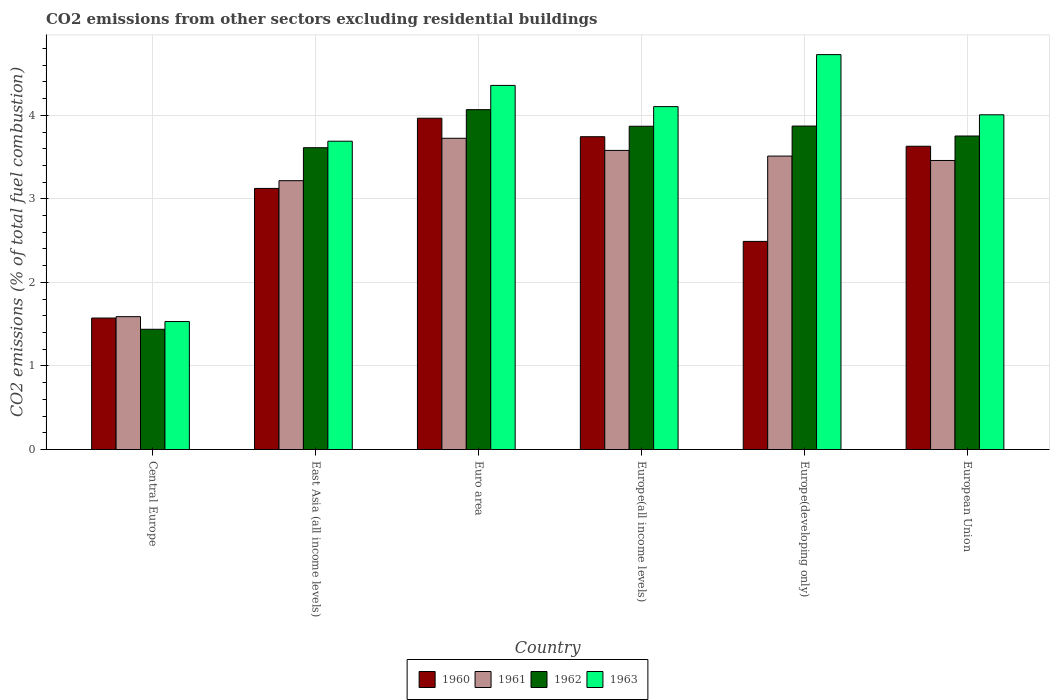Are the number of bars on each tick of the X-axis equal?
Keep it short and to the point. Yes. How many bars are there on the 5th tick from the left?
Offer a terse response. 4. How many bars are there on the 1st tick from the right?
Offer a very short reply. 4. What is the total CO2 emitted in 1961 in European Union?
Offer a terse response. 3.46. Across all countries, what is the maximum total CO2 emitted in 1960?
Ensure brevity in your answer.  3.97. Across all countries, what is the minimum total CO2 emitted in 1961?
Make the answer very short. 1.59. In which country was the total CO2 emitted in 1963 maximum?
Make the answer very short. Europe(developing only). In which country was the total CO2 emitted in 1961 minimum?
Your response must be concise. Central Europe. What is the total total CO2 emitted in 1960 in the graph?
Your response must be concise. 18.53. What is the difference between the total CO2 emitted in 1962 in East Asia (all income levels) and that in Europe(developing only)?
Provide a succinct answer. -0.26. What is the difference between the total CO2 emitted in 1962 in Europe(developing only) and the total CO2 emitted in 1960 in Euro area?
Your response must be concise. -0.09. What is the average total CO2 emitted in 1962 per country?
Offer a very short reply. 3.44. What is the difference between the total CO2 emitted of/in 1962 and total CO2 emitted of/in 1961 in Europe(developing only)?
Keep it short and to the point. 0.36. In how many countries, is the total CO2 emitted in 1960 greater than 1.6?
Provide a short and direct response. 5. What is the ratio of the total CO2 emitted in 1962 in Europe(all income levels) to that in European Union?
Offer a very short reply. 1.03. What is the difference between the highest and the second highest total CO2 emitted in 1960?
Provide a succinct answer. -0.22. What is the difference between the highest and the lowest total CO2 emitted in 1963?
Give a very brief answer. 3.19. In how many countries, is the total CO2 emitted in 1962 greater than the average total CO2 emitted in 1962 taken over all countries?
Make the answer very short. 5. Is the sum of the total CO2 emitted in 1960 in East Asia (all income levels) and Euro area greater than the maximum total CO2 emitted in 1963 across all countries?
Provide a short and direct response. Yes. Is it the case that in every country, the sum of the total CO2 emitted in 1960 and total CO2 emitted in 1963 is greater than the sum of total CO2 emitted in 1962 and total CO2 emitted in 1961?
Keep it short and to the point. No. What does the 4th bar from the right in Euro area represents?
Offer a terse response. 1960. Is it the case that in every country, the sum of the total CO2 emitted in 1962 and total CO2 emitted in 1960 is greater than the total CO2 emitted in 1961?
Offer a very short reply. Yes. How many bars are there?
Your response must be concise. 24. Are all the bars in the graph horizontal?
Offer a very short reply. No. How many countries are there in the graph?
Offer a terse response. 6. Does the graph contain grids?
Keep it short and to the point. Yes. What is the title of the graph?
Keep it short and to the point. CO2 emissions from other sectors excluding residential buildings. Does "1980" appear as one of the legend labels in the graph?
Your answer should be compact. No. What is the label or title of the Y-axis?
Your answer should be compact. CO2 emissions (% of total fuel combustion). What is the CO2 emissions (% of total fuel combustion) of 1960 in Central Europe?
Provide a short and direct response. 1.57. What is the CO2 emissions (% of total fuel combustion) of 1961 in Central Europe?
Keep it short and to the point. 1.59. What is the CO2 emissions (% of total fuel combustion) in 1962 in Central Europe?
Provide a short and direct response. 1.44. What is the CO2 emissions (% of total fuel combustion) of 1963 in Central Europe?
Provide a short and direct response. 1.53. What is the CO2 emissions (% of total fuel combustion) in 1960 in East Asia (all income levels)?
Keep it short and to the point. 3.13. What is the CO2 emissions (% of total fuel combustion) in 1961 in East Asia (all income levels)?
Provide a succinct answer. 3.22. What is the CO2 emissions (% of total fuel combustion) in 1962 in East Asia (all income levels)?
Provide a succinct answer. 3.61. What is the CO2 emissions (% of total fuel combustion) of 1963 in East Asia (all income levels)?
Keep it short and to the point. 3.69. What is the CO2 emissions (% of total fuel combustion) in 1960 in Euro area?
Offer a very short reply. 3.97. What is the CO2 emissions (% of total fuel combustion) of 1961 in Euro area?
Keep it short and to the point. 3.73. What is the CO2 emissions (% of total fuel combustion) of 1962 in Euro area?
Ensure brevity in your answer.  4.07. What is the CO2 emissions (% of total fuel combustion) in 1963 in Euro area?
Your answer should be very brief. 4.36. What is the CO2 emissions (% of total fuel combustion) in 1960 in Europe(all income levels)?
Keep it short and to the point. 3.74. What is the CO2 emissions (% of total fuel combustion) in 1961 in Europe(all income levels)?
Your answer should be compact. 3.58. What is the CO2 emissions (% of total fuel combustion) in 1962 in Europe(all income levels)?
Keep it short and to the point. 3.87. What is the CO2 emissions (% of total fuel combustion) in 1963 in Europe(all income levels)?
Provide a short and direct response. 4.1. What is the CO2 emissions (% of total fuel combustion) of 1960 in Europe(developing only)?
Your response must be concise. 2.49. What is the CO2 emissions (% of total fuel combustion) in 1961 in Europe(developing only)?
Your answer should be compact. 3.51. What is the CO2 emissions (% of total fuel combustion) of 1962 in Europe(developing only)?
Ensure brevity in your answer.  3.87. What is the CO2 emissions (% of total fuel combustion) in 1963 in Europe(developing only)?
Your response must be concise. 4.73. What is the CO2 emissions (% of total fuel combustion) of 1960 in European Union?
Give a very brief answer. 3.63. What is the CO2 emissions (% of total fuel combustion) in 1961 in European Union?
Keep it short and to the point. 3.46. What is the CO2 emissions (% of total fuel combustion) of 1962 in European Union?
Give a very brief answer. 3.75. What is the CO2 emissions (% of total fuel combustion) of 1963 in European Union?
Your response must be concise. 4.01. Across all countries, what is the maximum CO2 emissions (% of total fuel combustion) of 1960?
Keep it short and to the point. 3.97. Across all countries, what is the maximum CO2 emissions (% of total fuel combustion) of 1961?
Your answer should be very brief. 3.73. Across all countries, what is the maximum CO2 emissions (% of total fuel combustion) in 1962?
Offer a terse response. 4.07. Across all countries, what is the maximum CO2 emissions (% of total fuel combustion) of 1963?
Offer a very short reply. 4.73. Across all countries, what is the minimum CO2 emissions (% of total fuel combustion) in 1960?
Ensure brevity in your answer.  1.57. Across all countries, what is the minimum CO2 emissions (% of total fuel combustion) of 1961?
Ensure brevity in your answer.  1.59. Across all countries, what is the minimum CO2 emissions (% of total fuel combustion) in 1962?
Provide a succinct answer. 1.44. Across all countries, what is the minimum CO2 emissions (% of total fuel combustion) of 1963?
Give a very brief answer. 1.53. What is the total CO2 emissions (% of total fuel combustion) of 1960 in the graph?
Give a very brief answer. 18.53. What is the total CO2 emissions (% of total fuel combustion) in 1961 in the graph?
Make the answer very short. 19.08. What is the total CO2 emissions (% of total fuel combustion) in 1962 in the graph?
Provide a short and direct response. 20.61. What is the total CO2 emissions (% of total fuel combustion) in 1963 in the graph?
Offer a terse response. 22.42. What is the difference between the CO2 emissions (% of total fuel combustion) in 1960 in Central Europe and that in East Asia (all income levels)?
Keep it short and to the point. -1.55. What is the difference between the CO2 emissions (% of total fuel combustion) of 1961 in Central Europe and that in East Asia (all income levels)?
Keep it short and to the point. -1.63. What is the difference between the CO2 emissions (% of total fuel combustion) in 1962 in Central Europe and that in East Asia (all income levels)?
Offer a terse response. -2.17. What is the difference between the CO2 emissions (% of total fuel combustion) of 1963 in Central Europe and that in East Asia (all income levels)?
Offer a terse response. -2.16. What is the difference between the CO2 emissions (% of total fuel combustion) of 1960 in Central Europe and that in Euro area?
Your answer should be very brief. -2.39. What is the difference between the CO2 emissions (% of total fuel combustion) in 1961 in Central Europe and that in Euro area?
Provide a short and direct response. -2.14. What is the difference between the CO2 emissions (% of total fuel combustion) in 1962 in Central Europe and that in Euro area?
Make the answer very short. -2.63. What is the difference between the CO2 emissions (% of total fuel combustion) in 1963 in Central Europe and that in Euro area?
Ensure brevity in your answer.  -2.83. What is the difference between the CO2 emissions (% of total fuel combustion) of 1960 in Central Europe and that in Europe(all income levels)?
Offer a terse response. -2.17. What is the difference between the CO2 emissions (% of total fuel combustion) of 1961 in Central Europe and that in Europe(all income levels)?
Make the answer very short. -1.99. What is the difference between the CO2 emissions (% of total fuel combustion) in 1962 in Central Europe and that in Europe(all income levels)?
Your answer should be very brief. -2.43. What is the difference between the CO2 emissions (% of total fuel combustion) in 1963 in Central Europe and that in Europe(all income levels)?
Your answer should be very brief. -2.57. What is the difference between the CO2 emissions (% of total fuel combustion) of 1960 in Central Europe and that in Europe(developing only)?
Offer a very short reply. -0.92. What is the difference between the CO2 emissions (% of total fuel combustion) in 1961 in Central Europe and that in Europe(developing only)?
Give a very brief answer. -1.92. What is the difference between the CO2 emissions (% of total fuel combustion) of 1962 in Central Europe and that in Europe(developing only)?
Make the answer very short. -2.43. What is the difference between the CO2 emissions (% of total fuel combustion) in 1963 in Central Europe and that in Europe(developing only)?
Ensure brevity in your answer.  -3.19. What is the difference between the CO2 emissions (% of total fuel combustion) of 1960 in Central Europe and that in European Union?
Your answer should be compact. -2.06. What is the difference between the CO2 emissions (% of total fuel combustion) in 1961 in Central Europe and that in European Union?
Offer a terse response. -1.87. What is the difference between the CO2 emissions (% of total fuel combustion) in 1962 in Central Europe and that in European Union?
Your answer should be compact. -2.31. What is the difference between the CO2 emissions (% of total fuel combustion) of 1963 in Central Europe and that in European Union?
Your answer should be very brief. -2.47. What is the difference between the CO2 emissions (% of total fuel combustion) in 1960 in East Asia (all income levels) and that in Euro area?
Your answer should be very brief. -0.84. What is the difference between the CO2 emissions (% of total fuel combustion) of 1961 in East Asia (all income levels) and that in Euro area?
Your answer should be compact. -0.51. What is the difference between the CO2 emissions (% of total fuel combustion) of 1962 in East Asia (all income levels) and that in Euro area?
Keep it short and to the point. -0.46. What is the difference between the CO2 emissions (% of total fuel combustion) in 1963 in East Asia (all income levels) and that in Euro area?
Provide a short and direct response. -0.67. What is the difference between the CO2 emissions (% of total fuel combustion) in 1960 in East Asia (all income levels) and that in Europe(all income levels)?
Your answer should be very brief. -0.62. What is the difference between the CO2 emissions (% of total fuel combustion) of 1961 in East Asia (all income levels) and that in Europe(all income levels)?
Keep it short and to the point. -0.36. What is the difference between the CO2 emissions (% of total fuel combustion) in 1962 in East Asia (all income levels) and that in Europe(all income levels)?
Make the answer very short. -0.26. What is the difference between the CO2 emissions (% of total fuel combustion) in 1963 in East Asia (all income levels) and that in Europe(all income levels)?
Offer a terse response. -0.41. What is the difference between the CO2 emissions (% of total fuel combustion) in 1960 in East Asia (all income levels) and that in Europe(developing only)?
Provide a succinct answer. 0.63. What is the difference between the CO2 emissions (% of total fuel combustion) in 1961 in East Asia (all income levels) and that in Europe(developing only)?
Keep it short and to the point. -0.29. What is the difference between the CO2 emissions (% of total fuel combustion) of 1962 in East Asia (all income levels) and that in Europe(developing only)?
Offer a very short reply. -0.26. What is the difference between the CO2 emissions (% of total fuel combustion) in 1963 in East Asia (all income levels) and that in Europe(developing only)?
Your answer should be very brief. -1.04. What is the difference between the CO2 emissions (% of total fuel combustion) of 1960 in East Asia (all income levels) and that in European Union?
Offer a terse response. -0.5. What is the difference between the CO2 emissions (% of total fuel combustion) in 1961 in East Asia (all income levels) and that in European Union?
Your response must be concise. -0.24. What is the difference between the CO2 emissions (% of total fuel combustion) in 1962 in East Asia (all income levels) and that in European Union?
Keep it short and to the point. -0.14. What is the difference between the CO2 emissions (% of total fuel combustion) of 1963 in East Asia (all income levels) and that in European Union?
Your response must be concise. -0.32. What is the difference between the CO2 emissions (% of total fuel combustion) of 1960 in Euro area and that in Europe(all income levels)?
Ensure brevity in your answer.  0.22. What is the difference between the CO2 emissions (% of total fuel combustion) of 1961 in Euro area and that in Europe(all income levels)?
Offer a very short reply. 0.15. What is the difference between the CO2 emissions (% of total fuel combustion) of 1962 in Euro area and that in Europe(all income levels)?
Your answer should be compact. 0.2. What is the difference between the CO2 emissions (% of total fuel combustion) of 1963 in Euro area and that in Europe(all income levels)?
Your answer should be compact. 0.25. What is the difference between the CO2 emissions (% of total fuel combustion) in 1960 in Euro area and that in Europe(developing only)?
Make the answer very short. 1.47. What is the difference between the CO2 emissions (% of total fuel combustion) of 1961 in Euro area and that in Europe(developing only)?
Provide a succinct answer. 0.21. What is the difference between the CO2 emissions (% of total fuel combustion) of 1962 in Euro area and that in Europe(developing only)?
Provide a succinct answer. 0.2. What is the difference between the CO2 emissions (% of total fuel combustion) of 1963 in Euro area and that in Europe(developing only)?
Provide a succinct answer. -0.37. What is the difference between the CO2 emissions (% of total fuel combustion) of 1960 in Euro area and that in European Union?
Provide a succinct answer. 0.34. What is the difference between the CO2 emissions (% of total fuel combustion) in 1961 in Euro area and that in European Union?
Your response must be concise. 0.27. What is the difference between the CO2 emissions (% of total fuel combustion) of 1962 in Euro area and that in European Union?
Ensure brevity in your answer.  0.32. What is the difference between the CO2 emissions (% of total fuel combustion) in 1963 in Euro area and that in European Union?
Offer a very short reply. 0.35. What is the difference between the CO2 emissions (% of total fuel combustion) in 1960 in Europe(all income levels) and that in Europe(developing only)?
Your response must be concise. 1.25. What is the difference between the CO2 emissions (% of total fuel combustion) of 1961 in Europe(all income levels) and that in Europe(developing only)?
Provide a short and direct response. 0.07. What is the difference between the CO2 emissions (% of total fuel combustion) in 1962 in Europe(all income levels) and that in Europe(developing only)?
Offer a very short reply. -0. What is the difference between the CO2 emissions (% of total fuel combustion) of 1963 in Europe(all income levels) and that in Europe(developing only)?
Offer a very short reply. -0.62. What is the difference between the CO2 emissions (% of total fuel combustion) of 1960 in Europe(all income levels) and that in European Union?
Offer a terse response. 0.11. What is the difference between the CO2 emissions (% of total fuel combustion) of 1961 in Europe(all income levels) and that in European Union?
Your answer should be very brief. 0.12. What is the difference between the CO2 emissions (% of total fuel combustion) in 1962 in Europe(all income levels) and that in European Union?
Keep it short and to the point. 0.12. What is the difference between the CO2 emissions (% of total fuel combustion) of 1963 in Europe(all income levels) and that in European Union?
Offer a very short reply. 0.1. What is the difference between the CO2 emissions (% of total fuel combustion) of 1960 in Europe(developing only) and that in European Union?
Offer a terse response. -1.14. What is the difference between the CO2 emissions (% of total fuel combustion) of 1961 in Europe(developing only) and that in European Union?
Provide a succinct answer. 0.05. What is the difference between the CO2 emissions (% of total fuel combustion) of 1962 in Europe(developing only) and that in European Union?
Provide a succinct answer. 0.12. What is the difference between the CO2 emissions (% of total fuel combustion) in 1963 in Europe(developing only) and that in European Union?
Ensure brevity in your answer.  0.72. What is the difference between the CO2 emissions (% of total fuel combustion) in 1960 in Central Europe and the CO2 emissions (% of total fuel combustion) in 1961 in East Asia (all income levels)?
Provide a succinct answer. -1.64. What is the difference between the CO2 emissions (% of total fuel combustion) of 1960 in Central Europe and the CO2 emissions (% of total fuel combustion) of 1962 in East Asia (all income levels)?
Offer a very short reply. -2.04. What is the difference between the CO2 emissions (% of total fuel combustion) in 1960 in Central Europe and the CO2 emissions (% of total fuel combustion) in 1963 in East Asia (all income levels)?
Keep it short and to the point. -2.12. What is the difference between the CO2 emissions (% of total fuel combustion) in 1961 in Central Europe and the CO2 emissions (% of total fuel combustion) in 1962 in East Asia (all income levels)?
Keep it short and to the point. -2.02. What is the difference between the CO2 emissions (% of total fuel combustion) of 1961 in Central Europe and the CO2 emissions (% of total fuel combustion) of 1963 in East Asia (all income levels)?
Make the answer very short. -2.1. What is the difference between the CO2 emissions (% of total fuel combustion) in 1962 in Central Europe and the CO2 emissions (% of total fuel combustion) in 1963 in East Asia (all income levels)?
Your answer should be compact. -2.25. What is the difference between the CO2 emissions (% of total fuel combustion) of 1960 in Central Europe and the CO2 emissions (% of total fuel combustion) of 1961 in Euro area?
Provide a short and direct response. -2.15. What is the difference between the CO2 emissions (% of total fuel combustion) in 1960 in Central Europe and the CO2 emissions (% of total fuel combustion) in 1962 in Euro area?
Provide a short and direct response. -2.49. What is the difference between the CO2 emissions (% of total fuel combustion) of 1960 in Central Europe and the CO2 emissions (% of total fuel combustion) of 1963 in Euro area?
Offer a terse response. -2.78. What is the difference between the CO2 emissions (% of total fuel combustion) of 1961 in Central Europe and the CO2 emissions (% of total fuel combustion) of 1962 in Euro area?
Make the answer very short. -2.48. What is the difference between the CO2 emissions (% of total fuel combustion) in 1961 in Central Europe and the CO2 emissions (% of total fuel combustion) in 1963 in Euro area?
Keep it short and to the point. -2.77. What is the difference between the CO2 emissions (% of total fuel combustion) of 1962 in Central Europe and the CO2 emissions (% of total fuel combustion) of 1963 in Euro area?
Offer a very short reply. -2.92. What is the difference between the CO2 emissions (% of total fuel combustion) of 1960 in Central Europe and the CO2 emissions (% of total fuel combustion) of 1961 in Europe(all income levels)?
Your answer should be very brief. -2.01. What is the difference between the CO2 emissions (% of total fuel combustion) in 1960 in Central Europe and the CO2 emissions (% of total fuel combustion) in 1962 in Europe(all income levels)?
Your answer should be compact. -2.3. What is the difference between the CO2 emissions (% of total fuel combustion) in 1960 in Central Europe and the CO2 emissions (% of total fuel combustion) in 1963 in Europe(all income levels)?
Provide a short and direct response. -2.53. What is the difference between the CO2 emissions (% of total fuel combustion) in 1961 in Central Europe and the CO2 emissions (% of total fuel combustion) in 1962 in Europe(all income levels)?
Ensure brevity in your answer.  -2.28. What is the difference between the CO2 emissions (% of total fuel combustion) in 1961 in Central Europe and the CO2 emissions (% of total fuel combustion) in 1963 in Europe(all income levels)?
Make the answer very short. -2.51. What is the difference between the CO2 emissions (% of total fuel combustion) in 1962 in Central Europe and the CO2 emissions (% of total fuel combustion) in 1963 in Europe(all income levels)?
Offer a terse response. -2.67. What is the difference between the CO2 emissions (% of total fuel combustion) in 1960 in Central Europe and the CO2 emissions (% of total fuel combustion) in 1961 in Europe(developing only)?
Keep it short and to the point. -1.94. What is the difference between the CO2 emissions (% of total fuel combustion) in 1960 in Central Europe and the CO2 emissions (% of total fuel combustion) in 1962 in Europe(developing only)?
Offer a terse response. -2.3. What is the difference between the CO2 emissions (% of total fuel combustion) in 1960 in Central Europe and the CO2 emissions (% of total fuel combustion) in 1963 in Europe(developing only)?
Give a very brief answer. -3.15. What is the difference between the CO2 emissions (% of total fuel combustion) in 1961 in Central Europe and the CO2 emissions (% of total fuel combustion) in 1962 in Europe(developing only)?
Give a very brief answer. -2.28. What is the difference between the CO2 emissions (% of total fuel combustion) in 1961 in Central Europe and the CO2 emissions (% of total fuel combustion) in 1963 in Europe(developing only)?
Provide a short and direct response. -3.14. What is the difference between the CO2 emissions (% of total fuel combustion) of 1962 in Central Europe and the CO2 emissions (% of total fuel combustion) of 1963 in Europe(developing only)?
Your response must be concise. -3.29. What is the difference between the CO2 emissions (% of total fuel combustion) in 1960 in Central Europe and the CO2 emissions (% of total fuel combustion) in 1961 in European Union?
Your response must be concise. -1.89. What is the difference between the CO2 emissions (% of total fuel combustion) of 1960 in Central Europe and the CO2 emissions (% of total fuel combustion) of 1962 in European Union?
Ensure brevity in your answer.  -2.18. What is the difference between the CO2 emissions (% of total fuel combustion) in 1960 in Central Europe and the CO2 emissions (% of total fuel combustion) in 1963 in European Union?
Ensure brevity in your answer.  -2.43. What is the difference between the CO2 emissions (% of total fuel combustion) in 1961 in Central Europe and the CO2 emissions (% of total fuel combustion) in 1962 in European Union?
Keep it short and to the point. -2.16. What is the difference between the CO2 emissions (% of total fuel combustion) in 1961 in Central Europe and the CO2 emissions (% of total fuel combustion) in 1963 in European Union?
Provide a succinct answer. -2.42. What is the difference between the CO2 emissions (% of total fuel combustion) of 1962 in Central Europe and the CO2 emissions (% of total fuel combustion) of 1963 in European Union?
Offer a terse response. -2.57. What is the difference between the CO2 emissions (% of total fuel combustion) in 1960 in East Asia (all income levels) and the CO2 emissions (% of total fuel combustion) in 1961 in Euro area?
Give a very brief answer. -0.6. What is the difference between the CO2 emissions (% of total fuel combustion) in 1960 in East Asia (all income levels) and the CO2 emissions (% of total fuel combustion) in 1962 in Euro area?
Your answer should be compact. -0.94. What is the difference between the CO2 emissions (% of total fuel combustion) in 1960 in East Asia (all income levels) and the CO2 emissions (% of total fuel combustion) in 1963 in Euro area?
Your answer should be very brief. -1.23. What is the difference between the CO2 emissions (% of total fuel combustion) of 1961 in East Asia (all income levels) and the CO2 emissions (% of total fuel combustion) of 1962 in Euro area?
Offer a terse response. -0.85. What is the difference between the CO2 emissions (% of total fuel combustion) in 1961 in East Asia (all income levels) and the CO2 emissions (% of total fuel combustion) in 1963 in Euro area?
Make the answer very short. -1.14. What is the difference between the CO2 emissions (% of total fuel combustion) in 1962 in East Asia (all income levels) and the CO2 emissions (% of total fuel combustion) in 1963 in Euro area?
Provide a short and direct response. -0.75. What is the difference between the CO2 emissions (% of total fuel combustion) of 1960 in East Asia (all income levels) and the CO2 emissions (% of total fuel combustion) of 1961 in Europe(all income levels)?
Give a very brief answer. -0.45. What is the difference between the CO2 emissions (% of total fuel combustion) of 1960 in East Asia (all income levels) and the CO2 emissions (% of total fuel combustion) of 1962 in Europe(all income levels)?
Your answer should be compact. -0.74. What is the difference between the CO2 emissions (% of total fuel combustion) in 1960 in East Asia (all income levels) and the CO2 emissions (% of total fuel combustion) in 1963 in Europe(all income levels)?
Your answer should be compact. -0.98. What is the difference between the CO2 emissions (% of total fuel combustion) of 1961 in East Asia (all income levels) and the CO2 emissions (% of total fuel combustion) of 1962 in Europe(all income levels)?
Offer a terse response. -0.65. What is the difference between the CO2 emissions (% of total fuel combustion) of 1961 in East Asia (all income levels) and the CO2 emissions (% of total fuel combustion) of 1963 in Europe(all income levels)?
Keep it short and to the point. -0.89. What is the difference between the CO2 emissions (% of total fuel combustion) of 1962 in East Asia (all income levels) and the CO2 emissions (% of total fuel combustion) of 1963 in Europe(all income levels)?
Make the answer very short. -0.49. What is the difference between the CO2 emissions (% of total fuel combustion) in 1960 in East Asia (all income levels) and the CO2 emissions (% of total fuel combustion) in 1961 in Europe(developing only)?
Ensure brevity in your answer.  -0.39. What is the difference between the CO2 emissions (% of total fuel combustion) in 1960 in East Asia (all income levels) and the CO2 emissions (% of total fuel combustion) in 1962 in Europe(developing only)?
Your answer should be compact. -0.75. What is the difference between the CO2 emissions (% of total fuel combustion) of 1960 in East Asia (all income levels) and the CO2 emissions (% of total fuel combustion) of 1963 in Europe(developing only)?
Provide a succinct answer. -1.6. What is the difference between the CO2 emissions (% of total fuel combustion) of 1961 in East Asia (all income levels) and the CO2 emissions (% of total fuel combustion) of 1962 in Europe(developing only)?
Provide a succinct answer. -0.65. What is the difference between the CO2 emissions (% of total fuel combustion) of 1961 in East Asia (all income levels) and the CO2 emissions (% of total fuel combustion) of 1963 in Europe(developing only)?
Your response must be concise. -1.51. What is the difference between the CO2 emissions (% of total fuel combustion) of 1962 in East Asia (all income levels) and the CO2 emissions (% of total fuel combustion) of 1963 in Europe(developing only)?
Your answer should be compact. -1.11. What is the difference between the CO2 emissions (% of total fuel combustion) of 1960 in East Asia (all income levels) and the CO2 emissions (% of total fuel combustion) of 1961 in European Union?
Your answer should be compact. -0.33. What is the difference between the CO2 emissions (% of total fuel combustion) of 1960 in East Asia (all income levels) and the CO2 emissions (% of total fuel combustion) of 1962 in European Union?
Offer a terse response. -0.63. What is the difference between the CO2 emissions (% of total fuel combustion) of 1960 in East Asia (all income levels) and the CO2 emissions (% of total fuel combustion) of 1963 in European Union?
Your response must be concise. -0.88. What is the difference between the CO2 emissions (% of total fuel combustion) of 1961 in East Asia (all income levels) and the CO2 emissions (% of total fuel combustion) of 1962 in European Union?
Make the answer very short. -0.53. What is the difference between the CO2 emissions (% of total fuel combustion) of 1961 in East Asia (all income levels) and the CO2 emissions (% of total fuel combustion) of 1963 in European Union?
Your response must be concise. -0.79. What is the difference between the CO2 emissions (% of total fuel combustion) of 1962 in East Asia (all income levels) and the CO2 emissions (% of total fuel combustion) of 1963 in European Union?
Provide a succinct answer. -0.39. What is the difference between the CO2 emissions (% of total fuel combustion) of 1960 in Euro area and the CO2 emissions (% of total fuel combustion) of 1961 in Europe(all income levels)?
Offer a terse response. 0.39. What is the difference between the CO2 emissions (% of total fuel combustion) in 1960 in Euro area and the CO2 emissions (% of total fuel combustion) in 1962 in Europe(all income levels)?
Keep it short and to the point. 0.1. What is the difference between the CO2 emissions (% of total fuel combustion) of 1960 in Euro area and the CO2 emissions (% of total fuel combustion) of 1963 in Europe(all income levels)?
Make the answer very short. -0.14. What is the difference between the CO2 emissions (% of total fuel combustion) in 1961 in Euro area and the CO2 emissions (% of total fuel combustion) in 1962 in Europe(all income levels)?
Offer a very short reply. -0.14. What is the difference between the CO2 emissions (% of total fuel combustion) in 1961 in Euro area and the CO2 emissions (% of total fuel combustion) in 1963 in Europe(all income levels)?
Offer a terse response. -0.38. What is the difference between the CO2 emissions (% of total fuel combustion) in 1962 in Euro area and the CO2 emissions (% of total fuel combustion) in 1963 in Europe(all income levels)?
Provide a succinct answer. -0.04. What is the difference between the CO2 emissions (% of total fuel combustion) in 1960 in Euro area and the CO2 emissions (% of total fuel combustion) in 1961 in Europe(developing only)?
Your answer should be compact. 0.45. What is the difference between the CO2 emissions (% of total fuel combustion) of 1960 in Euro area and the CO2 emissions (% of total fuel combustion) of 1962 in Europe(developing only)?
Your response must be concise. 0.09. What is the difference between the CO2 emissions (% of total fuel combustion) of 1960 in Euro area and the CO2 emissions (% of total fuel combustion) of 1963 in Europe(developing only)?
Ensure brevity in your answer.  -0.76. What is the difference between the CO2 emissions (% of total fuel combustion) of 1961 in Euro area and the CO2 emissions (% of total fuel combustion) of 1962 in Europe(developing only)?
Offer a terse response. -0.15. What is the difference between the CO2 emissions (% of total fuel combustion) of 1961 in Euro area and the CO2 emissions (% of total fuel combustion) of 1963 in Europe(developing only)?
Make the answer very short. -1. What is the difference between the CO2 emissions (% of total fuel combustion) in 1962 in Euro area and the CO2 emissions (% of total fuel combustion) in 1963 in Europe(developing only)?
Offer a very short reply. -0.66. What is the difference between the CO2 emissions (% of total fuel combustion) in 1960 in Euro area and the CO2 emissions (% of total fuel combustion) in 1961 in European Union?
Provide a succinct answer. 0.51. What is the difference between the CO2 emissions (% of total fuel combustion) of 1960 in Euro area and the CO2 emissions (% of total fuel combustion) of 1962 in European Union?
Ensure brevity in your answer.  0.21. What is the difference between the CO2 emissions (% of total fuel combustion) in 1960 in Euro area and the CO2 emissions (% of total fuel combustion) in 1963 in European Union?
Ensure brevity in your answer.  -0.04. What is the difference between the CO2 emissions (% of total fuel combustion) of 1961 in Euro area and the CO2 emissions (% of total fuel combustion) of 1962 in European Union?
Give a very brief answer. -0.03. What is the difference between the CO2 emissions (% of total fuel combustion) of 1961 in Euro area and the CO2 emissions (% of total fuel combustion) of 1963 in European Union?
Offer a very short reply. -0.28. What is the difference between the CO2 emissions (% of total fuel combustion) in 1962 in Euro area and the CO2 emissions (% of total fuel combustion) in 1963 in European Union?
Provide a short and direct response. 0.06. What is the difference between the CO2 emissions (% of total fuel combustion) of 1960 in Europe(all income levels) and the CO2 emissions (% of total fuel combustion) of 1961 in Europe(developing only)?
Your response must be concise. 0.23. What is the difference between the CO2 emissions (% of total fuel combustion) in 1960 in Europe(all income levels) and the CO2 emissions (% of total fuel combustion) in 1962 in Europe(developing only)?
Offer a terse response. -0.13. What is the difference between the CO2 emissions (% of total fuel combustion) in 1960 in Europe(all income levels) and the CO2 emissions (% of total fuel combustion) in 1963 in Europe(developing only)?
Your answer should be very brief. -0.98. What is the difference between the CO2 emissions (% of total fuel combustion) of 1961 in Europe(all income levels) and the CO2 emissions (% of total fuel combustion) of 1962 in Europe(developing only)?
Your response must be concise. -0.29. What is the difference between the CO2 emissions (% of total fuel combustion) of 1961 in Europe(all income levels) and the CO2 emissions (% of total fuel combustion) of 1963 in Europe(developing only)?
Keep it short and to the point. -1.15. What is the difference between the CO2 emissions (% of total fuel combustion) of 1962 in Europe(all income levels) and the CO2 emissions (% of total fuel combustion) of 1963 in Europe(developing only)?
Give a very brief answer. -0.86. What is the difference between the CO2 emissions (% of total fuel combustion) of 1960 in Europe(all income levels) and the CO2 emissions (% of total fuel combustion) of 1961 in European Union?
Offer a very short reply. 0.28. What is the difference between the CO2 emissions (% of total fuel combustion) in 1960 in Europe(all income levels) and the CO2 emissions (% of total fuel combustion) in 1962 in European Union?
Ensure brevity in your answer.  -0.01. What is the difference between the CO2 emissions (% of total fuel combustion) in 1960 in Europe(all income levels) and the CO2 emissions (% of total fuel combustion) in 1963 in European Union?
Your answer should be very brief. -0.26. What is the difference between the CO2 emissions (% of total fuel combustion) in 1961 in Europe(all income levels) and the CO2 emissions (% of total fuel combustion) in 1962 in European Union?
Offer a very short reply. -0.17. What is the difference between the CO2 emissions (% of total fuel combustion) of 1961 in Europe(all income levels) and the CO2 emissions (% of total fuel combustion) of 1963 in European Union?
Give a very brief answer. -0.43. What is the difference between the CO2 emissions (% of total fuel combustion) of 1962 in Europe(all income levels) and the CO2 emissions (% of total fuel combustion) of 1963 in European Union?
Offer a terse response. -0.14. What is the difference between the CO2 emissions (% of total fuel combustion) in 1960 in Europe(developing only) and the CO2 emissions (% of total fuel combustion) in 1961 in European Union?
Your answer should be compact. -0.97. What is the difference between the CO2 emissions (% of total fuel combustion) in 1960 in Europe(developing only) and the CO2 emissions (% of total fuel combustion) in 1962 in European Union?
Provide a succinct answer. -1.26. What is the difference between the CO2 emissions (% of total fuel combustion) of 1960 in Europe(developing only) and the CO2 emissions (% of total fuel combustion) of 1963 in European Union?
Keep it short and to the point. -1.52. What is the difference between the CO2 emissions (% of total fuel combustion) in 1961 in Europe(developing only) and the CO2 emissions (% of total fuel combustion) in 1962 in European Union?
Make the answer very short. -0.24. What is the difference between the CO2 emissions (% of total fuel combustion) in 1961 in Europe(developing only) and the CO2 emissions (% of total fuel combustion) in 1963 in European Union?
Your answer should be very brief. -0.49. What is the difference between the CO2 emissions (% of total fuel combustion) of 1962 in Europe(developing only) and the CO2 emissions (% of total fuel combustion) of 1963 in European Union?
Offer a terse response. -0.14. What is the average CO2 emissions (% of total fuel combustion) of 1960 per country?
Offer a very short reply. 3.09. What is the average CO2 emissions (% of total fuel combustion) in 1961 per country?
Keep it short and to the point. 3.18. What is the average CO2 emissions (% of total fuel combustion) in 1962 per country?
Give a very brief answer. 3.44. What is the average CO2 emissions (% of total fuel combustion) of 1963 per country?
Provide a short and direct response. 3.74. What is the difference between the CO2 emissions (% of total fuel combustion) in 1960 and CO2 emissions (% of total fuel combustion) in 1961 in Central Europe?
Offer a very short reply. -0.02. What is the difference between the CO2 emissions (% of total fuel combustion) of 1960 and CO2 emissions (% of total fuel combustion) of 1962 in Central Europe?
Provide a succinct answer. 0.13. What is the difference between the CO2 emissions (% of total fuel combustion) of 1960 and CO2 emissions (% of total fuel combustion) of 1963 in Central Europe?
Provide a succinct answer. 0.04. What is the difference between the CO2 emissions (% of total fuel combustion) in 1961 and CO2 emissions (% of total fuel combustion) in 1962 in Central Europe?
Your answer should be very brief. 0.15. What is the difference between the CO2 emissions (% of total fuel combustion) of 1961 and CO2 emissions (% of total fuel combustion) of 1963 in Central Europe?
Give a very brief answer. 0.06. What is the difference between the CO2 emissions (% of total fuel combustion) in 1962 and CO2 emissions (% of total fuel combustion) in 1963 in Central Europe?
Your answer should be compact. -0.09. What is the difference between the CO2 emissions (% of total fuel combustion) in 1960 and CO2 emissions (% of total fuel combustion) in 1961 in East Asia (all income levels)?
Your response must be concise. -0.09. What is the difference between the CO2 emissions (% of total fuel combustion) in 1960 and CO2 emissions (% of total fuel combustion) in 1962 in East Asia (all income levels)?
Provide a short and direct response. -0.49. What is the difference between the CO2 emissions (% of total fuel combustion) of 1960 and CO2 emissions (% of total fuel combustion) of 1963 in East Asia (all income levels)?
Your answer should be compact. -0.56. What is the difference between the CO2 emissions (% of total fuel combustion) of 1961 and CO2 emissions (% of total fuel combustion) of 1962 in East Asia (all income levels)?
Give a very brief answer. -0.39. What is the difference between the CO2 emissions (% of total fuel combustion) of 1961 and CO2 emissions (% of total fuel combustion) of 1963 in East Asia (all income levels)?
Your response must be concise. -0.47. What is the difference between the CO2 emissions (% of total fuel combustion) in 1962 and CO2 emissions (% of total fuel combustion) in 1963 in East Asia (all income levels)?
Offer a very short reply. -0.08. What is the difference between the CO2 emissions (% of total fuel combustion) in 1960 and CO2 emissions (% of total fuel combustion) in 1961 in Euro area?
Provide a succinct answer. 0.24. What is the difference between the CO2 emissions (% of total fuel combustion) of 1960 and CO2 emissions (% of total fuel combustion) of 1962 in Euro area?
Keep it short and to the point. -0.1. What is the difference between the CO2 emissions (% of total fuel combustion) of 1960 and CO2 emissions (% of total fuel combustion) of 1963 in Euro area?
Offer a very short reply. -0.39. What is the difference between the CO2 emissions (% of total fuel combustion) of 1961 and CO2 emissions (% of total fuel combustion) of 1962 in Euro area?
Your answer should be very brief. -0.34. What is the difference between the CO2 emissions (% of total fuel combustion) in 1961 and CO2 emissions (% of total fuel combustion) in 1963 in Euro area?
Ensure brevity in your answer.  -0.63. What is the difference between the CO2 emissions (% of total fuel combustion) in 1962 and CO2 emissions (% of total fuel combustion) in 1963 in Euro area?
Ensure brevity in your answer.  -0.29. What is the difference between the CO2 emissions (% of total fuel combustion) of 1960 and CO2 emissions (% of total fuel combustion) of 1961 in Europe(all income levels)?
Ensure brevity in your answer.  0.16. What is the difference between the CO2 emissions (% of total fuel combustion) of 1960 and CO2 emissions (% of total fuel combustion) of 1962 in Europe(all income levels)?
Your answer should be compact. -0.13. What is the difference between the CO2 emissions (% of total fuel combustion) of 1960 and CO2 emissions (% of total fuel combustion) of 1963 in Europe(all income levels)?
Offer a terse response. -0.36. What is the difference between the CO2 emissions (% of total fuel combustion) of 1961 and CO2 emissions (% of total fuel combustion) of 1962 in Europe(all income levels)?
Your answer should be very brief. -0.29. What is the difference between the CO2 emissions (% of total fuel combustion) in 1961 and CO2 emissions (% of total fuel combustion) in 1963 in Europe(all income levels)?
Offer a very short reply. -0.52. What is the difference between the CO2 emissions (% of total fuel combustion) of 1962 and CO2 emissions (% of total fuel combustion) of 1963 in Europe(all income levels)?
Your answer should be compact. -0.23. What is the difference between the CO2 emissions (% of total fuel combustion) in 1960 and CO2 emissions (% of total fuel combustion) in 1961 in Europe(developing only)?
Offer a very short reply. -1.02. What is the difference between the CO2 emissions (% of total fuel combustion) of 1960 and CO2 emissions (% of total fuel combustion) of 1962 in Europe(developing only)?
Provide a short and direct response. -1.38. What is the difference between the CO2 emissions (% of total fuel combustion) in 1960 and CO2 emissions (% of total fuel combustion) in 1963 in Europe(developing only)?
Make the answer very short. -2.24. What is the difference between the CO2 emissions (% of total fuel combustion) of 1961 and CO2 emissions (% of total fuel combustion) of 1962 in Europe(developing only)?
Keep it short and to the point. -0.36. What is the difference between the CO2 emissions (% of total fuel combustion) in 1961 and CO2 emissions (% of total fuel combustion) in 1963 in Europe(developing only)?
Ensure brevity in your answer.  -1.21. What is the difference between the CO2 emissions (% of total fuel combustion) in 1962 and CO2 emissions (% of total fuel combustion) in 1963 in Europe(developing only)?
Your answer should be very brief. -0.85. What is the difference between the CO2 emissions (% of total fuel combustion) of 1960 and CO2 emissions (% of total fuel combustion) of 1961 in European Union?
Make the answer very short. 0.17. What is the difference between the CO2 emissions (% of total fuel combustion) in 1960 and CO2 emissions (% of total fuel combustion) in 1962 in European Union?
Ensure brevity in your answer.  -0.12. What is the difference between the CO2 emissions (% of total fuel combustion) of 1960 and CO2 emissions (% of total fuel combustion) of 1963 in European Union?
Your response must be concise. -0.38. What is the difference between the CO2 emissions (% of total fuel combustion) of 1961 and CO2 emissions (% of total fuel combustion) of 1962 in European Union?
Your response must be concise. -0.29. What is the difference between the CO2 emissions (% of total fuel combustion) in 1961 and CO2 emissions (% of total fuel combustion) in 1963 in European Union?
Your answer should be very brief. -0.55. What is the difference between the CO2 emissions (% of total fuel combustion) of 1962 and CO2 emissions (% of total fuel combustion) of 1963 in European Union?
Give a very brief answer. -0.25. What is the ratio of the CO2 emissions (% of total fuel combustion) in 1960 in Central Europe to that in East Asia (all income levels)?
Your response must be concise. 0.5. What is the ratio of the CO2 emissions (% of total fuel combustion) of 1961 in Central Europe to that in East Asia (all income levels)?
Keep it short and to the point. 0.49. What is the ratio of the CO2 emissions (% of total fuel combustion) of 1962 in Central Europe to that in East Asia (all income levels)?
Ensure brevity in your answer.  0.4. What is the ratio of the CO2 emissions (% of total fuel combustion) in 1963 in Central Europe to that in East Asia (all income levels)?
Your answer should be very brief. 0.42. What is the ratio of the CO2 emissions (% of total fuel combustion) of 1960 in Central Europe to that in Euro area?
Keep it short and to the point. 0.4. What is the ratio of the CO2 emissions (% of total fuel combustion) of 1961 in Central Europe to that in Euro area?
Your answer should be compact. 0.43. What is the ratio of the CO2 emissions (% of total fuel combustion) in 1962 in Central Europe to that in Euro area?
Offer a very short reply. 0.35. What is the ratio of the CO2 emissions (% of total fuel combustion) in 1963 in Central Europe to that in Euro area?
Offer a very short reply. 0.35. What is the ratio of the CO2 emissions (% of total fuel combustion) of 1960 in Central Europe to that in Europe(all income levels)?
Make the answer very short. 0.42. What is the ratio of the CO2 emissions (% of total fuel combustion) of 1961 in Central Europe to that in Europe(all income levels)?
Offer a very short reply. 0.44. What is the ratio of the CO2 emissions (% of total fuel combustion) of 1962 in Central Europe to that in Europe(all income levels)?
Ensure brevity in your answer.  0.37. What is the ratio of the CO2 emissions (% of total fuel combustion) in 1963 in Central Europe to that in Europe(all income levels)?
Provide a succinct answer. 0.37. What is the ratio of the CO2 emissions (% of total fuel combustion) of 1960 in Central Europe to that in Europe(developing only)?
Offer a terse response. 0.63. What is the ratio of the CO2 emissions (% of total fuel combustion) of 1961 in Central Europe to that in Europe(developing only)?
Provide a short and direct response. 0.45. What is the ratio of the CO2 emissions (% of total fuel combustion) of 1962 in Central Europe to that in Europe(developing only)?
Offer a very short reply. 0.37. What is the ratio of the CO2 emissions (% of total fuel combustion) of 1963 in Central Europe to that in Europe(developing only)?
Your answer should be very brief. 0.32. What is the ratio of the CO2 emissions (% of total fuel combustion) in 1960 in Central Europe to that in European Union?
Make the answer very short. 0.43. What is the ratio of the CO2 emissions (% of total fuel combustion) of 1961 in Central Europe to that in European Union?
Offer a very short reply. 0.46. What is the ratio of the CO2 emissions (% of total fuel combustion) in 1962 in Central Europe to that in European Union?
Offer a very short reply. 0.38. What is the ratio of the CO2 emissions (% of total fuel combustion) in 1963 in Central Europe to that in European Union?
Your answer should be very brief. 0.38. What is the ratio of the CO2 emissions (% of total fuel combustion) in 1960 in East Asia (all income levels) to that in Euro area?
Provide a short and direct response. 0.79. What is the ratio of the CO2 emissions (% of total fuel combustion) of 1961 in East Asia (all income levels) to that in Euro area?
Offer a very short reply. 0.86. What is the ratio of the CO2 emissions (% of total fuel combustion) of 1962 in East Asia (all income levels) to that in Euro area?
Give a very brief answer. 0.89. What is the ratio of the CO2 emissions (% of total fuel combustion) in 1963 in East Asia (all income levels) to that in Euro area?
Provide a succinct answer. 0.85. What is the ratio of the CO2 emissions (% of total fuel combustion) in 1960 in East Asia (all income levels) to that in Europe(all income levels)?
Offer a very short reply. 0.83. What is the ratio of the CO2 emissions (% of total fuel combustion) in 1961 in East Asia (all income levels) to that in Europe(all income levels)?
Your response must be concise. 0.9. What is the ratio of the CO2 emissions (% of total fuel combustion) of 1962 in East Asia (all income levels) to that in Europe(all income levels)?
Your response must be concise. 0.93. What is the ratio of the CO2 emissions (% of total fuel combustion) in 1963 in East Asia (all income levels) to that in Europe(all income levels)?
Ensure brevity in your answer.  0.9. What is the ratio of the CO2 emissions (% of total fuel combustion) in 1960 in East Asia (all income levels) to that in Europe(developing only)?
Make the answer very short. 1.25. What is the ratio of the CO2 emissions (% of total fuel combustion) in 1961 in East Asia (all income levels) to that in Europe(developing only)?
Your response must be concise. 0.92. What is the ratio of the CO2 emissions (% of total fuel combustion) in 1962 in East Asia (all income levels) to that in Europe(developing only)?
Keep it short and to the point. 0.93. What is the ratio of the CO2 emissions (% of total fuel combustion) in 1963 in East Asia (all income levels) to that in Europe(developing only)?
Keep it short and to the point. 0.78. What is the ratio of the CO2 emissions (% of total fuel combustion) in 1960 in East Asia (all income levels) to that in European Union?
Provide a succinct answer. 0.86. What is the ratio of the CO2 emissions (% of total fuel combustion) in 1961 in East Asia (all income levels) to that in European Union?
Keep it short and to the point. 0.93. What is the ratio of the CO2 emissions (% of total fuel combustion) in 1962 in East Asia (all income levels) to that in European Union?
Give a very brief answer. 0.96. What is the ratio of the CO2 emissions (% of total fuel combustion) in 1963 in East Asia (all income levels) to that in European Union?
Offer a terse response. 0.92. What is the ratio of the CO2 emissions (% of total fuel combustion) of 1960 in Euro area to that in Europe(all income levels)?
Give a very brief answer. 1.06. What is the ratio of the CO2 emissions (% of total fuel combustion) in 1961 in Euro area to that in Europe(all income levels)?
Make the answer very short. 1.04. What is the ratio of the CO2 emissions (% of total fuel combustion) of 1962 in Euro area to that in Europe(all income levels)?
Make the answer very short. 1.05. What is the ratio of the CO2 emissions (% of total fuel combustion) of 1963 in Euro area to that in Europe(all income levels)?
Offer a terse response. 1.06. What is the ratio of the CO2 emissions (% of total fuel combustion) in 1960 in Euro area to that in Europe(developing only)?
Offer a terse response. 1.59. What is the ratio of the CO2 emissions (% of total fuel combustion) of 1961 in Euro area to that in Europe(developing only)?
Your response must be concise. 1.06. What is the ratio of the CO2 emissions (% of total fuel combustion) of 1962 in Euro area to that in Europe(developing only)?
Give a very brief answer. 1.05. What is the ratio of the CO2 emissions (% of total fuel combustion) of 1963 in Euro area to that in Europe(developing only)?
Ensure brevity in your answer.  0.92. What is the ratio of the CO2 emissions (% of total fuel combustion) of 1960 in Euro area to that in European Union?
Your answer should be very brief. 1.09. What is the ratio of the CO2 emissions (% of total fuel combustion) of 1961 in Euro area to that in European Union?
Your answer should be compact. 1.08. What is the ratio of the CO2 emissions (% of total fuel combustion) of 1962 in Euro area to that in European Union?
Ensure brevity in your answer.  1.08. What is the ratio of the CO2 emissions (% of total fuel combustion) in 1963 in Euro area to that in European Union?
Your answer should be compact. 1.09. What is the ratio of the CO2 emissions (% of total fuel combustion) in 1960 in Europe(all income levels) to that in Europe(developing only)?
Provide a short and direct response. 1.5. What is the ratio of the CO2 emissions (% of total fuel combustion) in 1961 in Europe(all income levels) to that in Europe(developing only)?
Provide a succinct answer. 1.02. What is the ratio of the CO2 emissions (% of total fuel combustion) in 1963 in Europe(all income levels) to that in Europe(developing only)?
Keep it short and to the point. 0.87. What is the ratio of the CO2 emissions (% of total fuel combustion) of 1960 in Europe(all income levels) to that in European Union?
Your answer should be compact. 1.03. What is the ratio of the CO2 emissions (% of total fuel combustion) of 1961 in Europe(all income levels) to that in European Union?
Provide a short and direct response. 1.03. What is the ratio of the CO2 emissions (% of total fuel combustion) in 1962 in Europe(all income levels) to that in European Union?
Provide a succinct answer. 1.03. What is the ratio of the CO2 emissions (% of total fuel combustion) of 1963 in Europe(all income levels) to that in European Union?
Ensure brevity in your answer.  1.02. What is the ratio of the CO2 emissions (% of total fuel combustion) in 1960 in Europe(developing only) to that in European Union?
Your answer should be compact. 0.69. What is the ratio of the CO2 emissions (% of total fuel combustion) in 1961 in Europe(developing only) to that in European Union?
Provide a short and direct response. 1.02. What is the ratio of the CO2 emissions (% of total fuel combustion) of 1962 in Europe(developing only) to that in European Union?
Keep it short and to the point. 1.03. What is the ratio of the CO2 emissions (% of total fuel combustion) of 1963 in Europe(developing only) to that in European Union?
Make the answer very short. 1.18. What is the difference between the highest and the second highest CO2 emissions (% of total fuel combustion) of 1960?
Provide a short and direct response. 0.22. What is the difference between the highest and the second highest CO2 emissions (% of total fuel combustion) in 1961?
Give a very brief answer. 0.15. What is the difference between the highest and the second highest CO2 emissions (% of total fuel combustion) in 1962?
Offer a very short reply. 0.2. What is the difference between the highest and the second highest CO2 emissions (% of total fuel combustion) of 1963?
Your answer should be compact. 0.37. What is the difference between the highest and the lowest CO2 emissions (% of total fuel combustion) of 1960?
Provide a short and direct response. 2.39. What is the difference between the highest and the lowest CO2 emissions (% of total fuel combustion) of 1961?
Ensure brevity in your answer.  2.14. What is the difference between the highest and the lowest CO2 emissions (% of total fuel combustion) in 1962?
Provide a succinct answer. 2.63. What is the difference between the highest and the lowest CO2 emissions (% of total fuel combustion) of 1963?
Your response must be concise. 3.19. 